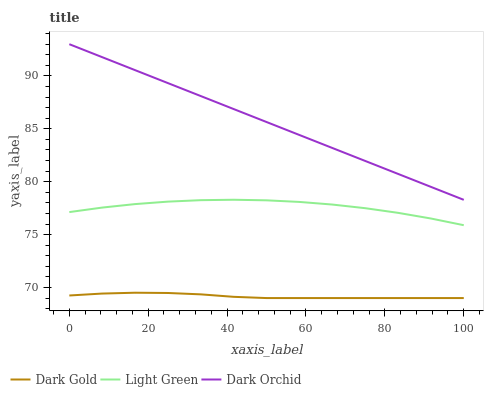Does Dark Gold have the minimum area under the curve?
Answer yes or no. Yes. Does Dark Orchid have the maximum area under the curve?
Answer yes or no. Yes. Does Light Green have the minimum area under the curve?
Answer yes or no. No. Does Light Green have the maximum area under the curve?
Answer yes or no. No. Is Dark Orchid the smoothest?
Answer yes or no. Yes. Is Light Green the roughest?
Answer yes or no. Yes. Is Dark Gold the smoothest?
Answer yes or no. No. Is Dark Gold the roughest?
Answer yes or no. No. Does Light Green have the lowest value?
Answer yes or no. No. Does Light Green have the highest value?
Answer yes or no. No. Is Dark Gold less than Light Green?
Answer yes or no. Yes. Is Dark Orchid greater than Dark Gold?
Answer yes or no. Yes. Does Dark Gold intersect Light Green?
Answer yes or no. No. 